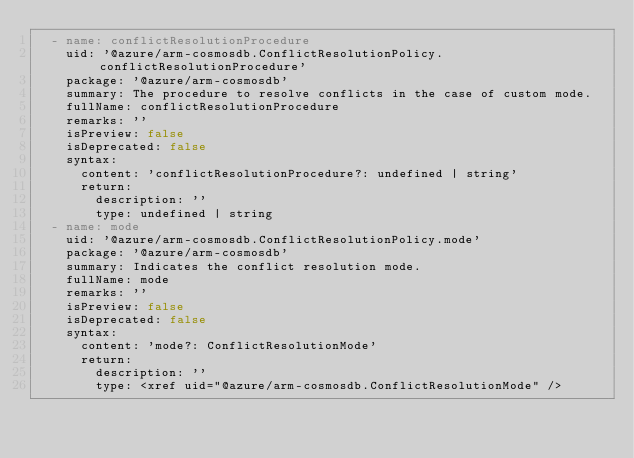Convert code to text. <code><loc_0><loc_0><loc_500><loc_500><_YAML_>  - name: conflictResolutionProcedure
    uid: '@azure/arm-cosmosdb.ConflictResolutionPolicy.conflictResolutionProcedure'
    package: '@azure/arm-cosmosdb'
    summary: The procedure to resolve conflicts in the case of custom mode.
    fullName: conflictResolutionProcedure
    remarks: ''
    isPreview: false
    isDeprecated: false
    syntax:
      content: 'conflictResolutionProcedure?: undefined | string'
      return:
        description: ''
        type: undefined | string
  - name: mode
    uid: '@azure/arm-cosmosdb.ConflictResolutionPolicy.mode'
    package: '@azure/arm-cosmosdb'
    summary: Indicates the conflict resolution mode.
    fullName: mode
    remarks: ''
    isPreview: false
    isDeprecated: false
    syntax:
      content: 'mode?: ConflictResolutionMode'
      return:
        description: ''
        type: <xref uid="@azure/arm-cosmosdb.ConflictResolutionMode" />
</code> 